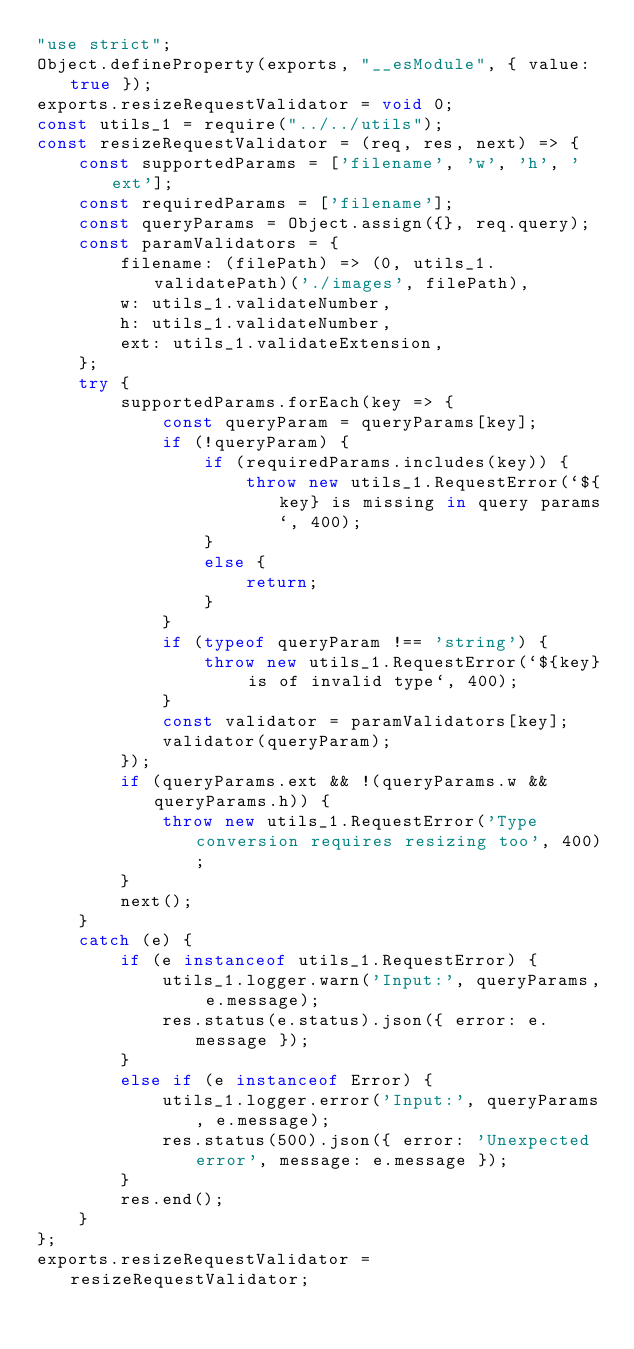<code> <loc_0><loc_0><loc_500><loc_500><_JavaScript_>"use strict";
Object.defineProperty(exports, "__esModule", { value: true });
exports.resizeRequestValidator = void 0;
const utils_1 = require("../../utils");
const resizeRequestValidator = (req, res, next) => {
    const supportedParams = ['filename', 'w', 'h', 'ext'];
    const requiredParams = ['filename'];
    const queryParams = Object.assign({}, req.query);
    const paramValidators = {
        filename: (filePath) => (0, utils_1.validatePath)('./images', filePath),
        w: utils_1.validateNumber,
        h: utils_1.validateNumber,
        ext: utils_1.validateExtension,
    };
    try {
        supportedParams.forEach(key => {
            const queryParam = queryParams[key];
            if (!queryParam) {
                if (requiredParams.includes(key)) {
                    throw new utils_1.RequestError(`${key} is missing in query params`, 400);
                }
                else {
                    return;
                }
            }
            if (typeof queryParam !== 'string') {
                throw new utils_1.RequestError(`${key} is of invalid type`, 400);
            }
            const validator = paramValidators[key];
            validator(queryParam);
        });
        if (queryParams.ext && !(queryParams.w && queryParams.h)) {
            throw new utils_1.RequestError('Type conversion requires resizing too', 400);
        }
        next();
    }
    catch (e) {
        if (e instanceof utils_1.RequestError) {
            utils_1.logger.warn('Input:', queryParams, e.message);
            res.status(e.status).json({ error: e.message });
        }
        else if (e instanceof Error) {
            utils_1.logger.error('Input:', queryParams, e.message);
            res.status(500).json({ error: 'Unexpected error', message: e.message });
        }
        res.end();
    }
};
exports.resizeRequestValidator = resizeRequestValidator;
</code> 